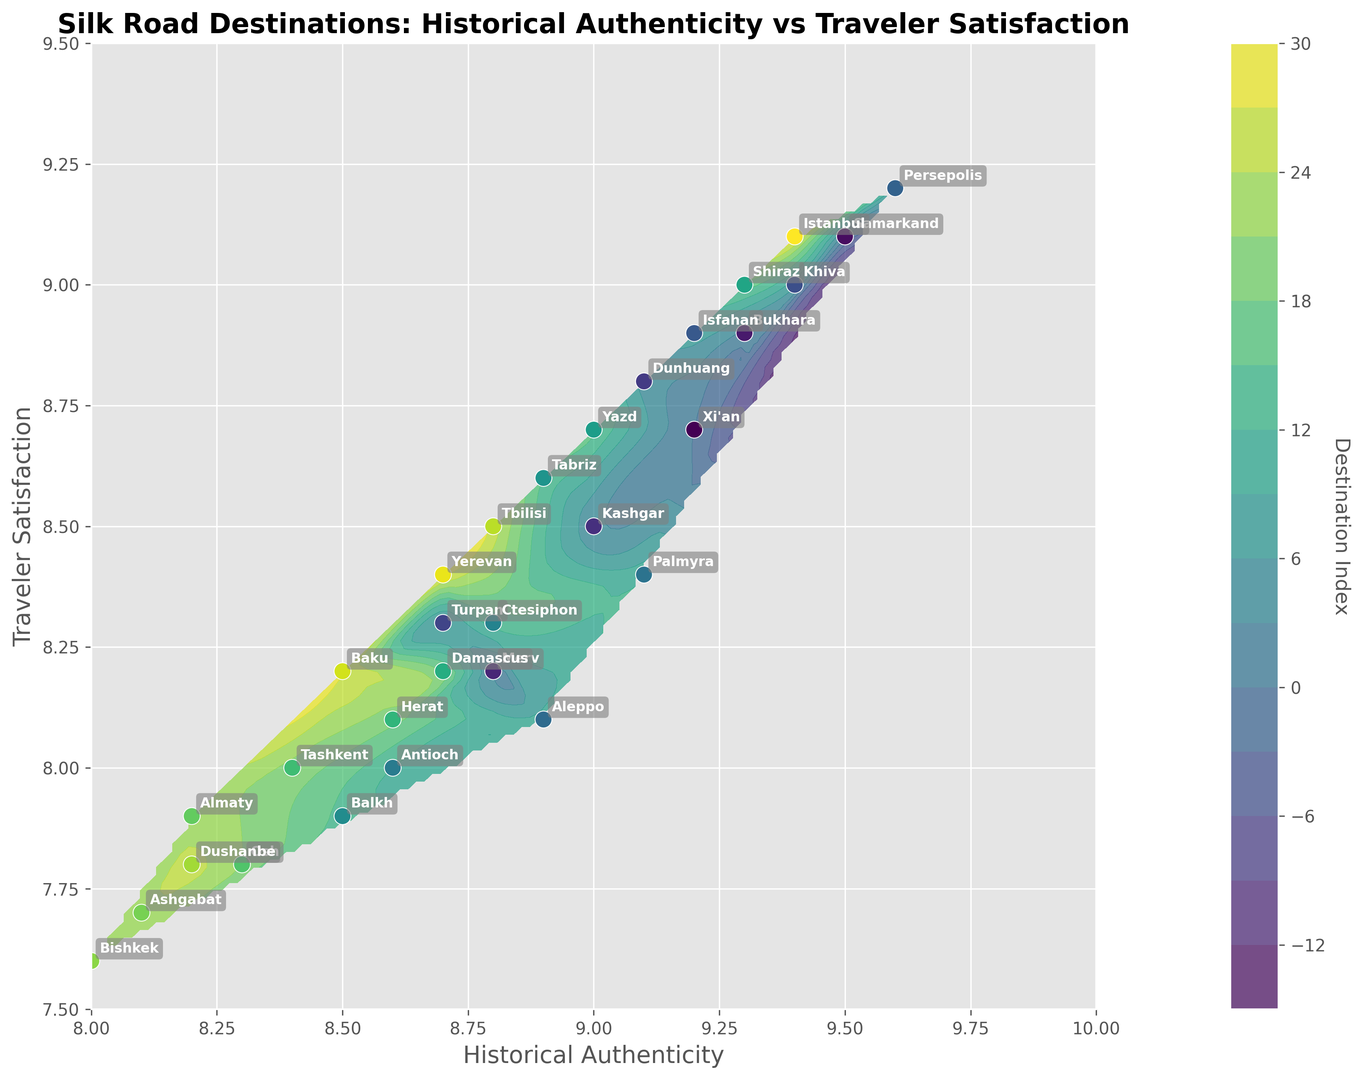Which destination has the highest traveler satisfaction rating? Look for the data point with the highest Y value on the scatter plot.
Answer: Persepolis Which destination has the lowest historical authenticity rating? Look for the data point with the lowest X value on the scatter plot.
Answer: Bishkek Is there a correlation between historical authenticity and traveler satisfaction? Examine the overall trend in the scatter plot; as X values increase from left to right, observe if Y values also increase.
Answer: Yes How does Xi'an's traveler satisfaction compare to Istanbul's? Compare the Y values of Xi'an and Istanbul on the scatter plot; Xi'an is around 8.7, and Istanbul is around 9.1.
Answer: Lower Which destination is closest to having both historical authenticity and traveler satisfaction ratings of 9.0? Find the data point closest to (9.0, 9.0) on the scatter plot by comparing nearby coordinates.
Answer: Khiva What is the average traveler satisfaction rating of destinations with a historical authenticity rating above 9.0? Identify the data points where X > 9.0 and calculate the average of their Y values: Khiva (9.0), Persepolis (9.2), Istanbul (9.1), Shiraz (9.0), Samarkand (9.1). Average = (9.0 + 9.2 + 9.1 + 9.0 + 9.1) / 5 = 9.08
Answer: 9.08 Which destination has a higher historical authenticity rating, Dunhuang or Kashgar? Compare the X values of Dunhuang and Kashgar on the scatter plot; Dunhuang has 9.1 and Kashgar has 9.0.
Answer: Dunhuang Are there more destinations with traveler satisfaction ratings above 8.5 or below 8.5? Count the number of Y values above and below 8.5. Above: 18, Below: 12.
Answer: Above Which destination pairs have equal traveler satisfaction ratings? Check destinations that overlap on the Y-axis in the scatter plot. Examples include Xi'an & Yazd (both 8.7), Dunhuang & Shiraz (both 9.0).
Answer: Xi'an & Yazd, Dunhuang & Shiraz What's the difference in historical authenticity ratings between Merv and Aleppo? Subtract the X value of Aleppo from Merv. Merv: 8.8, Aleppo: 8.9, Difference: 8.8-8.9 = -0.1
Answer: -0.1 